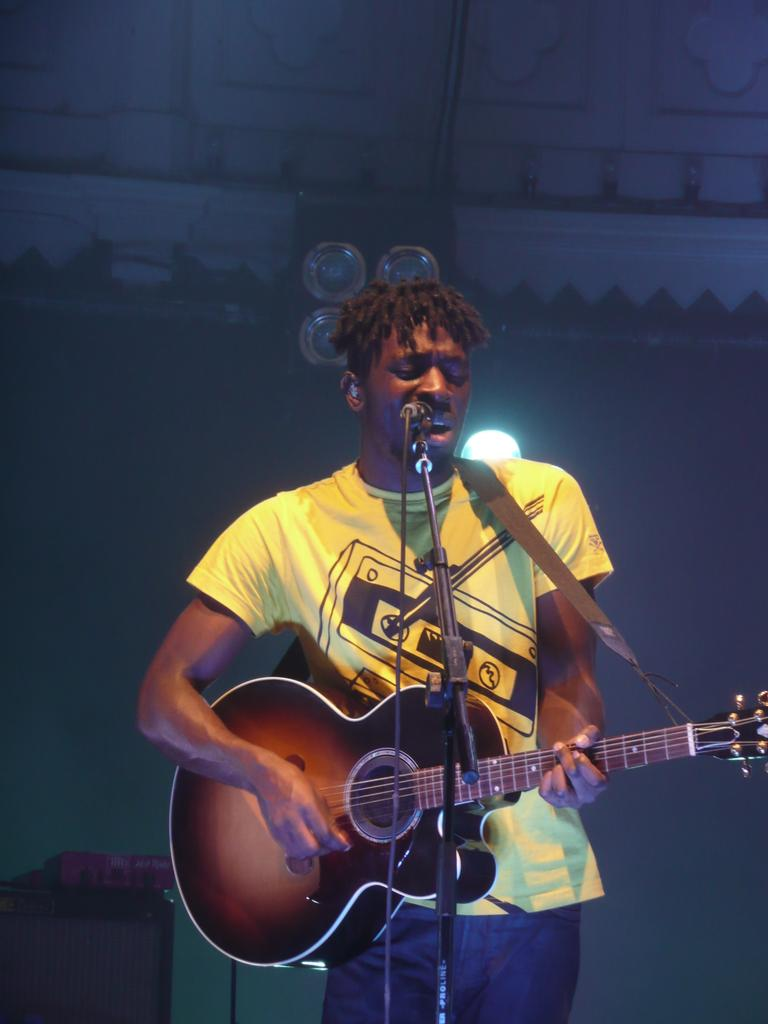What is the man in the image doing? The man is standing, playing a guitar, singing, and using a microphone. What instrument is the man playing in the image? The man is playing a guitar in the image. How is the man's voice being amplified in the image? The man is using a microphone to amplify his voice in the image. What type of rifle is the man holding in the image? There is no rifle present in the image; the man is holding a guitar and using a microphone. How many women are present in the image? There is no mention of women in the image; the image only features a man. 